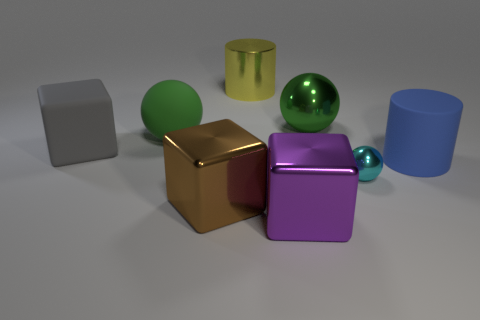Can you tell which object appears to be the heaviest and why? While it's impossible to know the actual weights without physical data, visually, the large gold-colored cube appears to be the heaviest due to its size and solid appearance. It's also in the central foreground, which can give a visual emphasis on its mass compared to the other objects. 